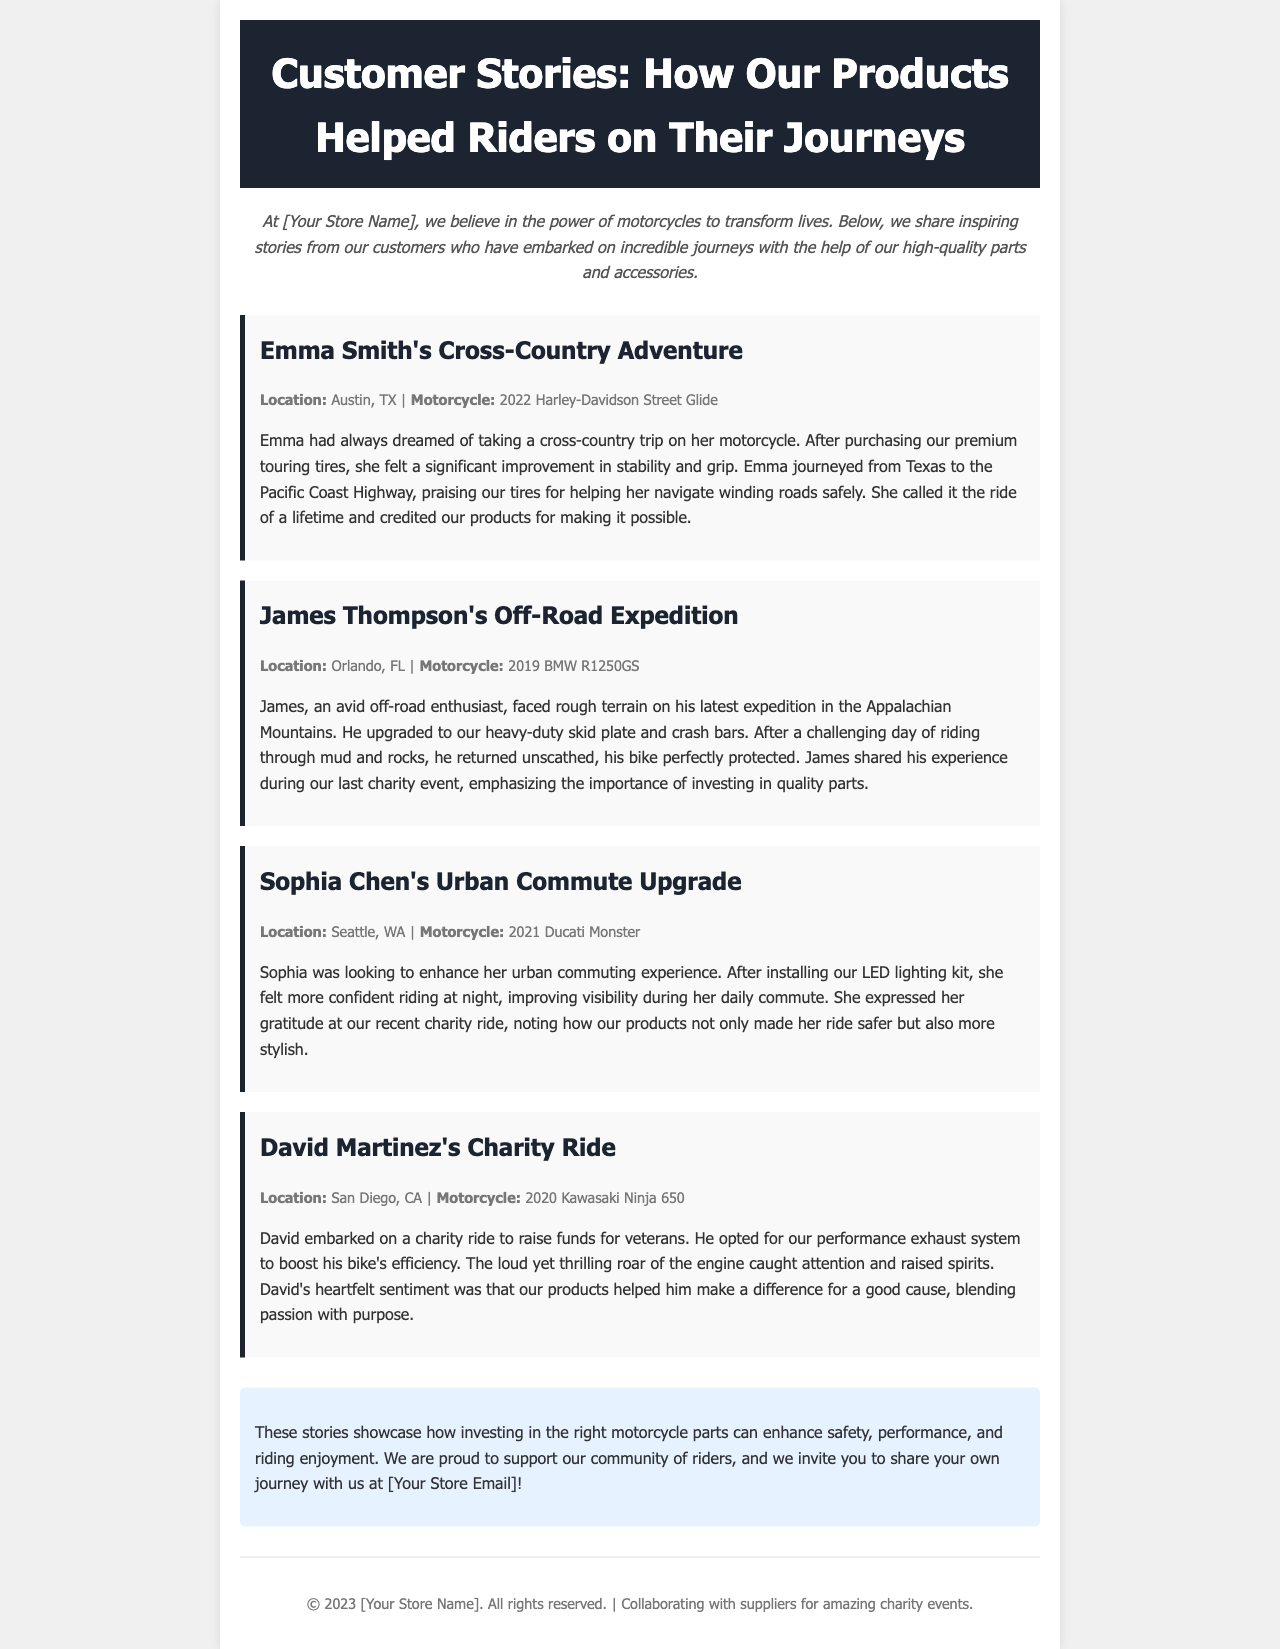what is the title of the newsletter? The title is prominently featured in the header section of the document.
Answer: Customer Stories: How Our Products Helped Riders on Their Journeys who shared their experience at the last charity event? Multiple stories in the document mention events; James specifically discussed his experience during a charity event.
Answer: James what motorcycle did Emma Smith ride? The document mentions specific motorcycles associated with each story, including Emma's.
Answer: 2022 Harley-Davidson Street Glide what product did Sophia Chen install to improve her night visibility? The specific product mentioned in Sophia's story is highlighted in the text to show how it helped her.
Answer: LED lighting kit how did David Martinez use our products for a charitable cause? David's story describes the purpose behind his ride and how the products contributed to it.
Answer: To raise funds for veterans what was the location of Emma Smith's adventure? Each story indicates the starting locations of the riders' journeys within the document.
Answer: Austin, TX which rider upgraded their motorcycle for off-road protection? The text identifies which rider made upgrades specifically for off-road riding challenges.
Answer: James Thompson what unique feature did David's exhaust system provide? The narrative of David's story indicates a specific characteristic of the exhaust system he chose.
Answer: Boosted his bike's efficiency how does the document invite readers to engage further? The conclusion encourages readers to share their own journey, indicating a call to action.
Answer: Share your own journey with us at [Your Store Email] 